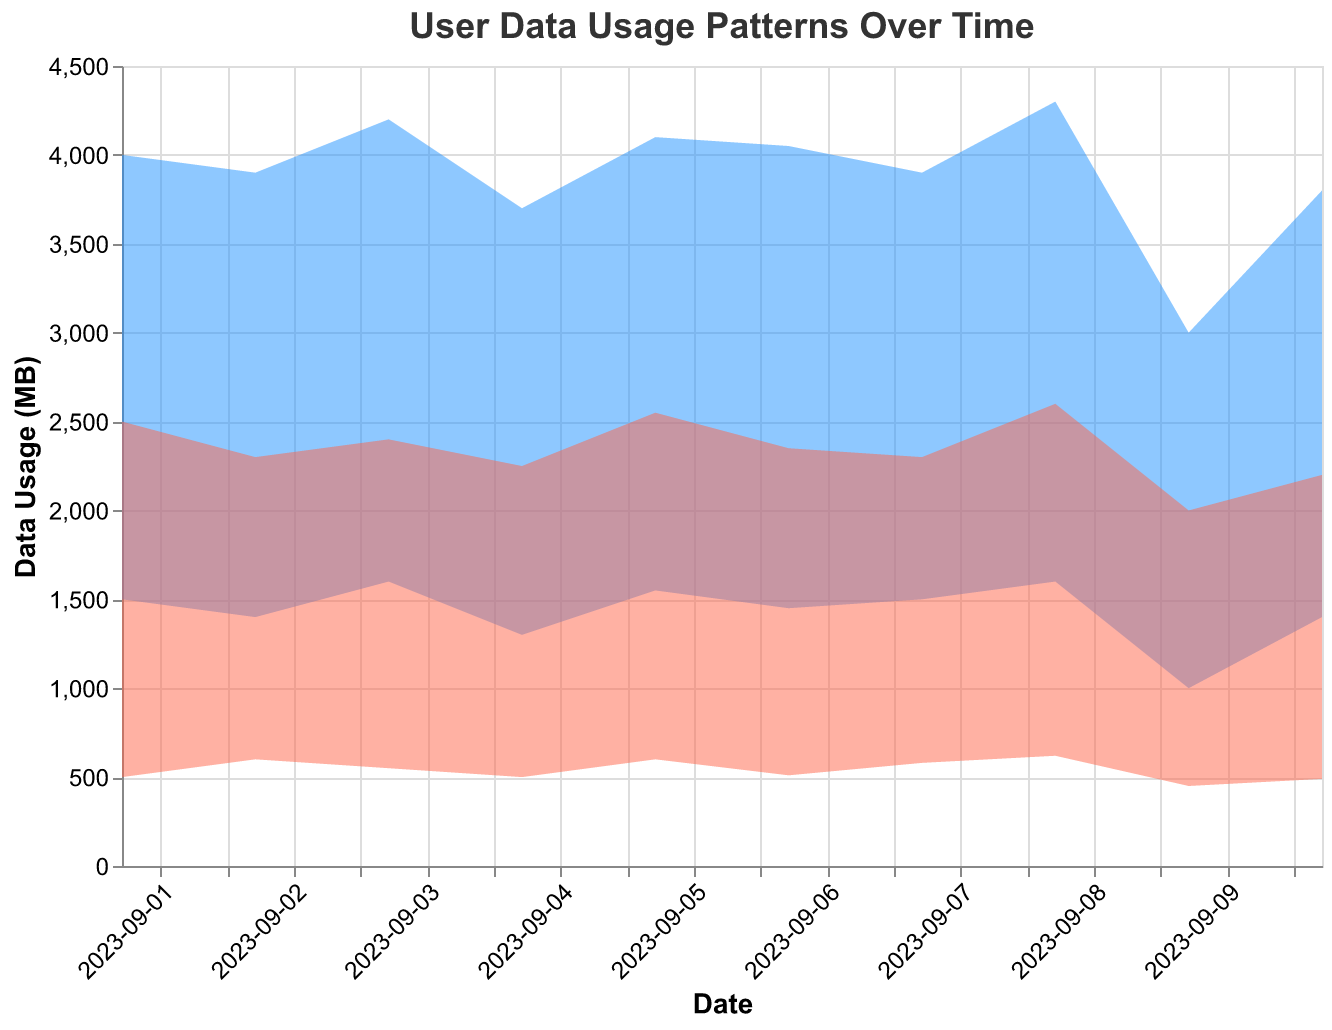What is the title of the chart? The title is usually found at the top center of the chart. Here it reads "User Data Usage Patterns Over Time".
Answer: User Data Usage Patterns Over Time What is the y-axis label and what does it represent? The y-axis label is found vertically along the left side of the chart and it represents "Data Usage (MB)", indicating the amount of data usage measured in megabytes.
Answer: Data Usage (MB) On which date was the peak hour max usage the highest? By examining the upper boundary of the blue shaded area, we notice that on 2023-09-08, the peak hour max usage is the highest at 4300 MB.
Answer: 2023-09-08 How does peak hour usage on 2023-09-09 compare to other days? Observing the blue area band for peak usage on 2023-09-09 shows that both the min and max values (1000 MB and 3000 MB) are noticeably lower than those on most other days.
Answer: Lower Which has a greater variance, peak hour usage or off-peak hour usage? Variance can be visually estimated by observing the height difference between the top and bottom boundary lines of the shaded areas. Peak hours (blue area) have a greater variance compared to off-peak hours (red area), with larger differences between the min and max values across the days.
Answer: Peak hour usage On which dates are the min off-peak usage values the same? The red shaded area, showing off-peak usage, has the same lower boundary of 500 MB on dates 2023-09-01 and 2023-09-04.
Answer: 2023-09-01 and 2023-09-04 What is the range of data usage during peak hours on 2023-09-05? The peak hour usage range can be seen in the blue area band for 2023-09-05, which ranges from a minimum of 1550 MB to a maximum of 4100 MB.
Answer: 1550 MB to 4100 MB Between which dates does off-peak max usage show an increasing trend? Observing the top boundary of the red area band for off-peak usage, there is a noticeable increasing trend from 2023-09-06 (2350 MB) to 2023-09-08 (2600 MB).
Answer: 2023-09-06 to 2023-09-08 